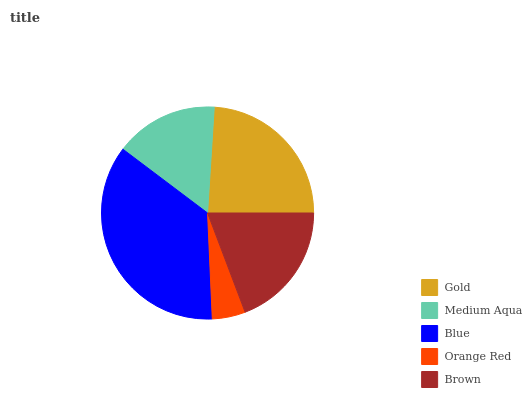Is Orange Red the minimum?
Answer yes or no. Yes. Is Blue the maximum?
Answer yes or no. Yes. Is Medium Aqua the minimum?
Answer yes or no. No. Is Medium Aqua the maximum?
Answer yes or no. No. Is Gold greater than Medium Aqua?
Answer yes or no. Yes. Is Medium Aqua less than Gold?
Answer yes or no. Yes. Is Medium Aqua greater than Gold?
Answer yes or no. No. Is Gold less than Medium Aqua?
Answer yes or no. No. Is Brown the high median?
Answer yes or no. Yes. Is Brown the low median?
Answer yes or no. Yes. Is Gold the high median?
Answer yes or no. No. Is Blue the low median?
Answer yes or no. No. 